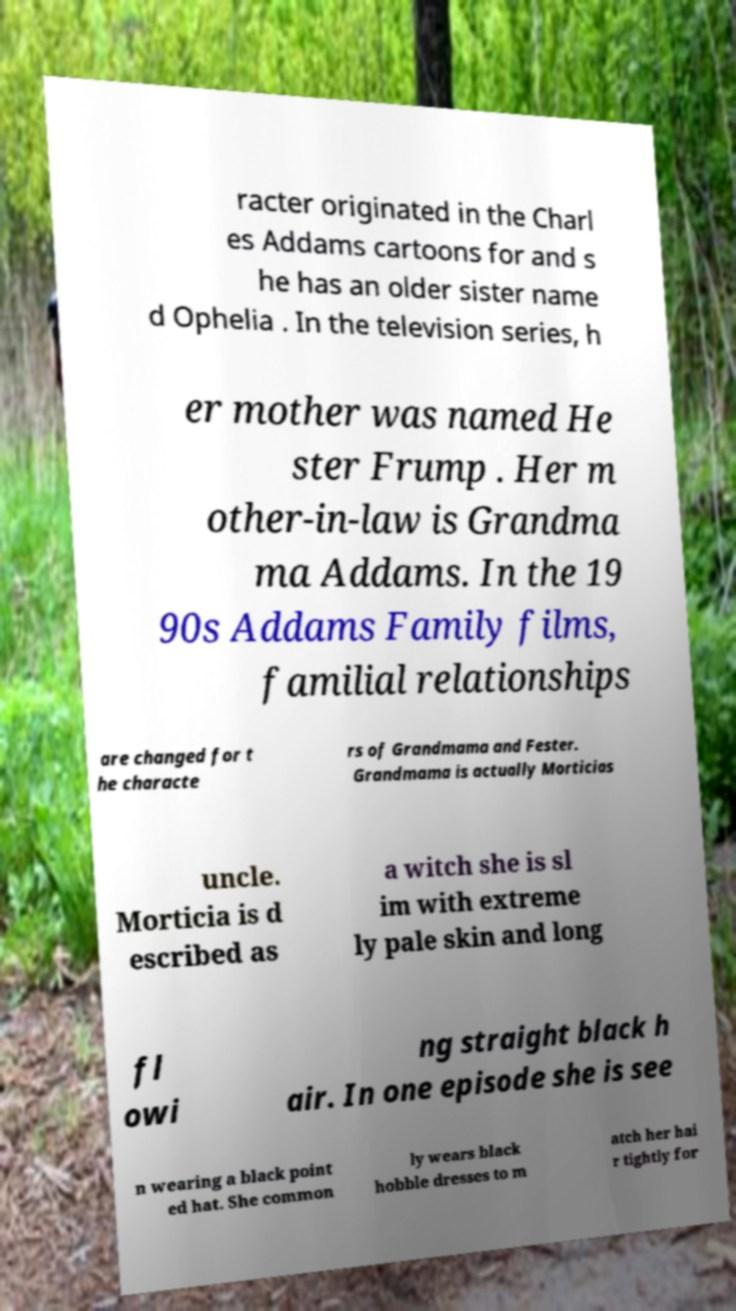I need the written content from this picture converted into text. Can you do that? racter originated in the Charl es Addams cartoons for and s he has an older sister name d Ophelia . In the television series, h er mother was named He ster Frump . Her m other-in-law is Grandma ma Addams. In the 19 90s Addams Family films, familial relationships are changed for t he characte rs of Grandmama and Fester. Grandmama is actually Morticias uncle. Morticia is d escribed as a witch she is sl im with extreme ly pale skin and long fl owi ng straight black h air. In one episode she is see n wearing a black point ed hat. She common ly wears black hobble dresses to m atch her hai r tightly for 